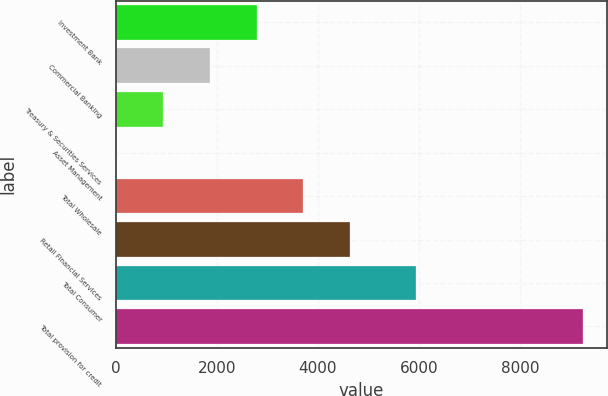<chart> <loc_0><loc_0><loc_500><loc_500><bar_chart><fcel>Investment Bank<fcel>Commercial Banking<fcel>Treasury & Securities Services<fcel>Asset Management<fcel>Total Wholesale<fcel>Retail Financial Services<fcel>Total Consumer<fcel>Total provision for credit<nl><fcel>2785.8<fcel>1863.2<fcel>940.6<fcel>18<fcel>3708.4<fcel>4631<fcel>5930<fcel>9244<nl></chart> 